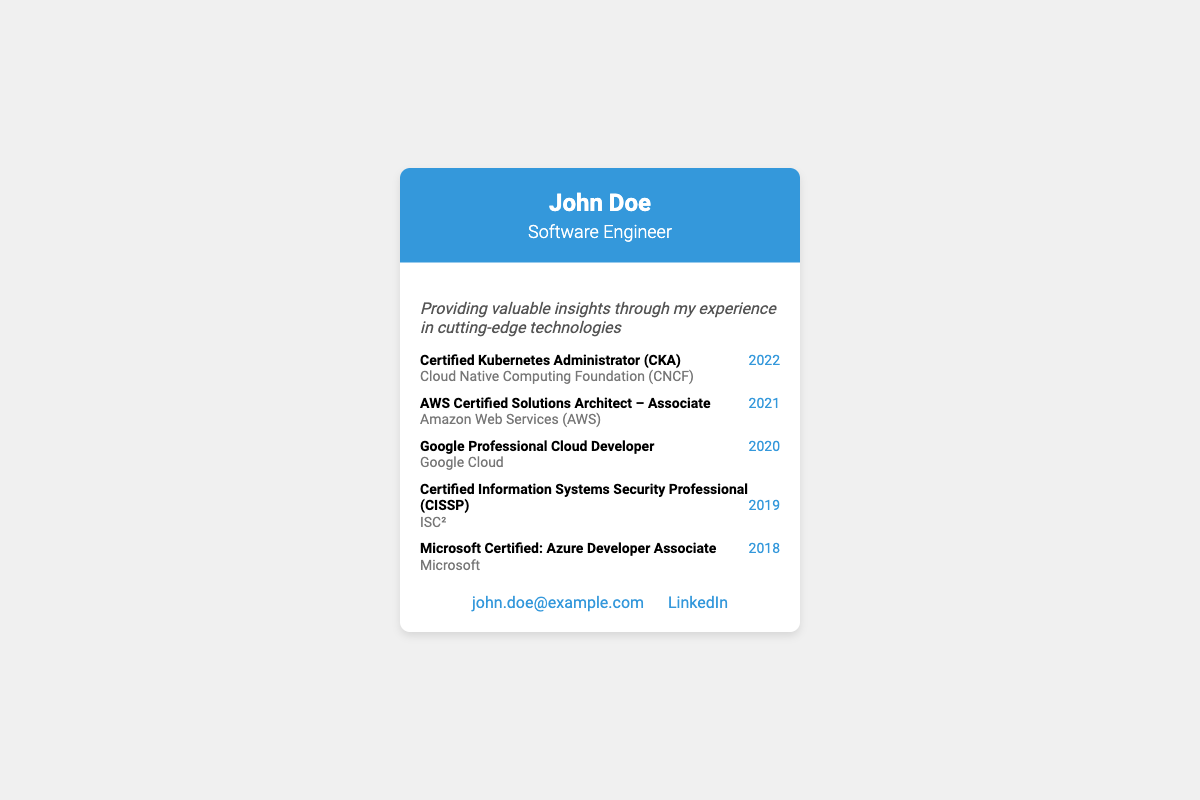What is the name on the business card? The name on the business card is clearly displayed at the top in large font.
Answer: John Doe What is the title of the individual? The title is indicated right below the name, specifying the individual's profession.
Answer: Software Engineer Which certification was completed in 2022? The certifications are listed chronologically, making it easy to identify the one completed in that year.
Answer: Certified Kubernetes Administrator (CKA) Who issued the AWS Certified Solutions Architect certification? Each certification has the issuer noted right below it, providing this information.
Answer: Amazon Web Services (AWS) What year was the Microsoft Certified: Azure Developer Associate certification completed? The year of completion is listed next to each certification, allowing for straightforward retrieval.
Answer: 2018 What does the insight on the card emphasize? The insight provides a brief statement about the individual's professional focus, found in the content section.
Answer: Valuable insights Which social media platform is mentioned for contact? The social media platform is indicated in the contact section, detailing where to find the individual online.
Answer: LinkedIn How many certifications are listed on the card? By counting the items in the certifications section, the total can be easily determined.
Answer: Five What type of card is this document presenting? The overall layout and design align with standard characteristics of this document type.
Answer: Business card 